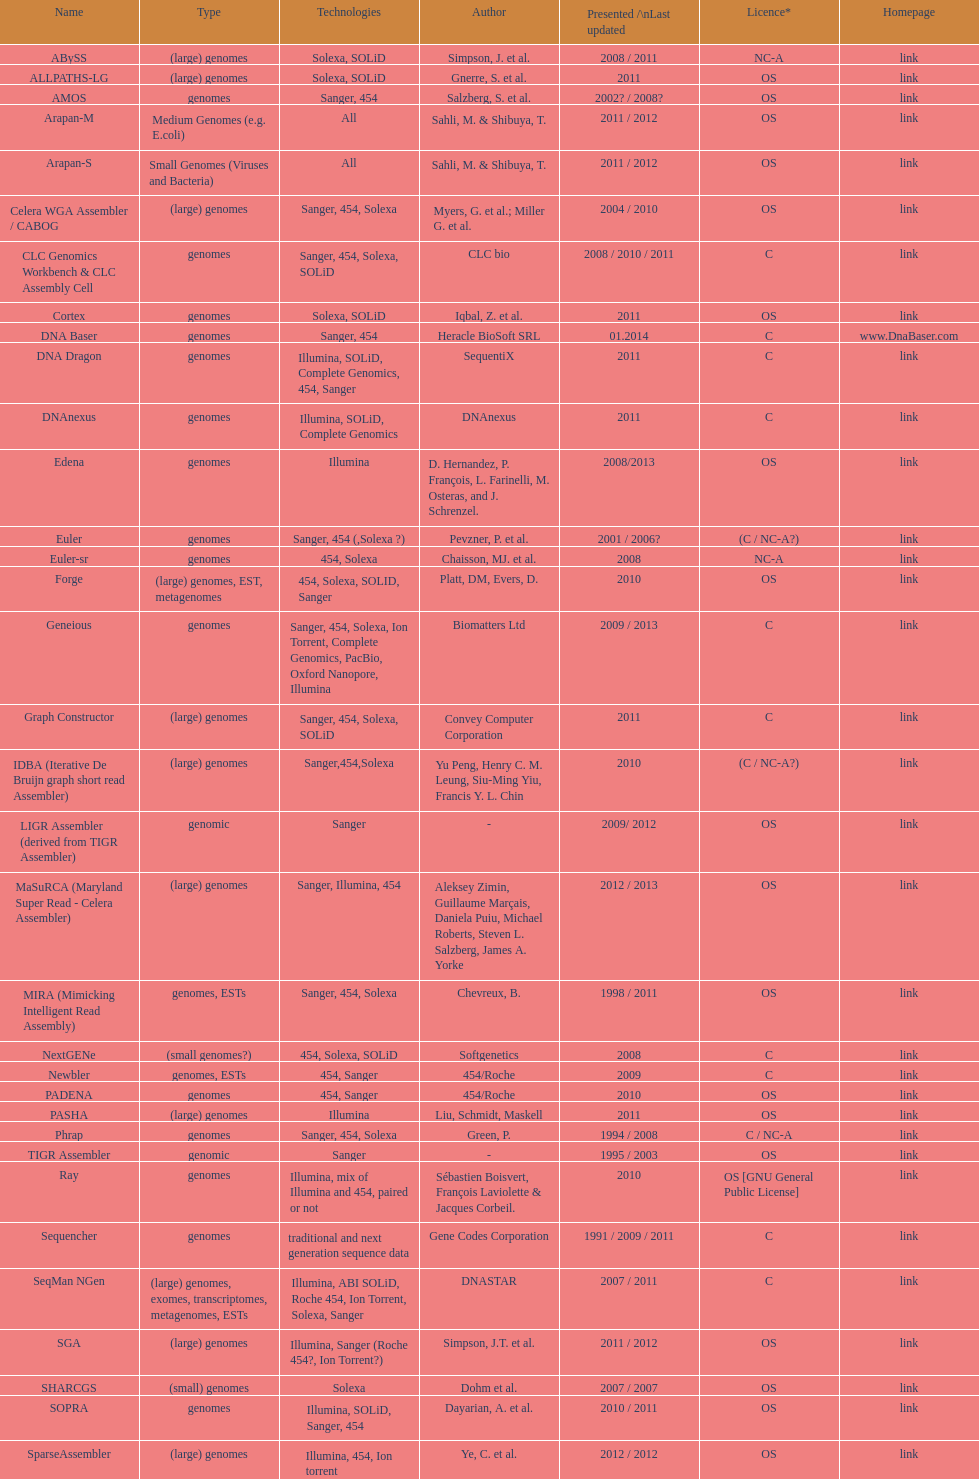What is the newest display or modified? DNA Baser. 